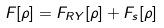Convert formula to latex. <formula><loc_0><loc_0><loc_500><loc_500>F [ \rho ] = F _ { R Y } [ \rho ] + F _ { s } [ \rho ]</formula> 